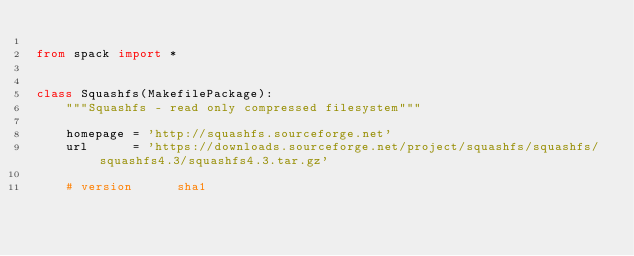Convert code to text. <code><loc_0><loc_0><loc_500><loc_500><_Python_>
from spack import *


class Squashfs(MakefilePackage):
    """Squashfs - read only compressed filesystem"""

    homepage = 'http://squashfs.sourceforge.net'
    url      = 'https://downloads.sourceforge.net/project/squashfs/squashfs/squashfs4.3/squashfs4.3.tar.gz'

    # version      sha1</code> 